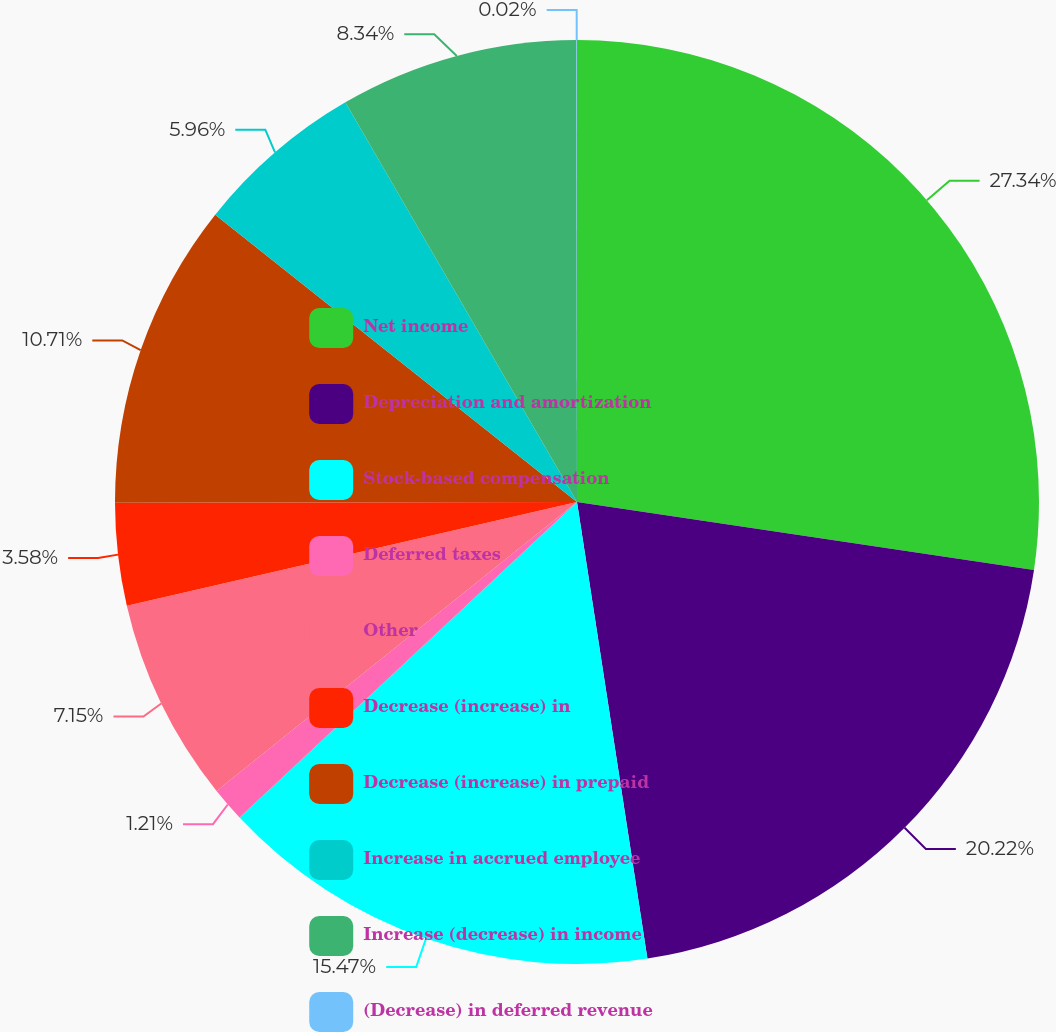<chart> <loc_0><loc_0><loc_500><loc_500><pie_chart><fcel>Net income<fcel>Depreciation and amortization<fcel>Stock-based compensation<fcel>Deferred taxes<fcel>Other<fcel>Decrease (increase) in<fcel>Decrease (increase) in prepaid<fcel>Increase in accrued employee<fcel>Increase (decrease) in income<fcel>(Decrease) in deferred revenue<nl><fcel>27.35%<fcel>20.22%<fcel>15.47%<fcel>1.21%<fcel>7.15%<fcel>3.58%<fcel>10.71%<fcel>5.96%<fcel>8.34%<fcel>0.02%<nl></chart> 